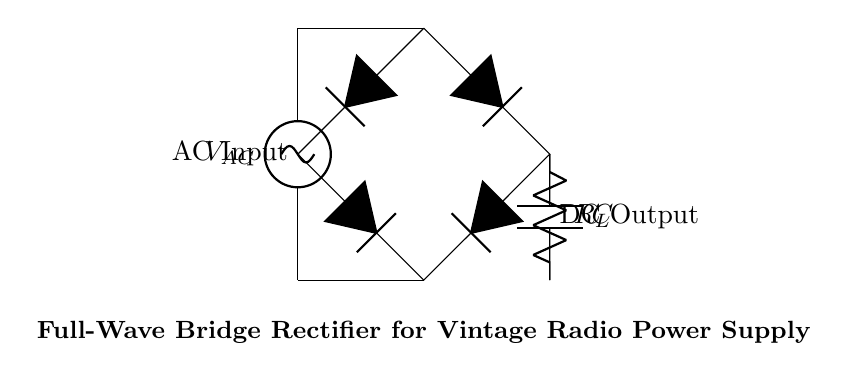What is the type of power input for this circuit? The circuit uses AC power as indicated by the label on the voltage source at the top of the circuit, which shows 'VAC'. This signifies it is alternating current.
Answer: AC What components are used in the rectifier configuration? The circuit diagram includes four diodes, a capacitor, and a load resistor. These are standard components for a full-wave bridge rectifier.
Answer: Diodes, capacitor, resistor What is the output type of this rectifier circuit? The circuit's output is DC, as indicated by the label 'DC Output' at the bottom, which reflects that this rectifier converts AC to DC.
Answer: DC How many diodes are used in the bridge rectifier? The diagram shows four diodes forming the bridge part of the rectifier, which is characteristic of this type of circuit to convert both halves of the AC cycle.
Answer: Four What is the role of the capacitor in the circuit? The capacitor is used for smoothing the output voltage by filtering the rectified signal, reducing voltage ripple, which is critical in power supply applications for stable DC output.
Answer: Smoothing What happens to the output voltage when the load resistor increases? Increasing the load resistor will generally result in an increase in output voltage (as long as the power source can maintain the voltage) because it reduces the load current, thus minimizing the voltage drop across the rectifier.
Answer: Increases What is the overall function of this circuit? The main function is to convert alternating current into direct current for use in the power supply of vintage radios, ensuring that the radios work reliably and efficiently.
Answer: AC to DC conversion 